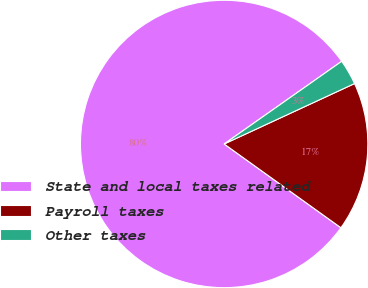<chart> <loc_0><loc_0><loc_500><loc_500><pie_chart><fcel>State and local taxes related<fcel>Payroll taxes<fcel>Other taxes<nl><fcel>80.34%<fcel>16.81%<fcel>2.85%<nl></chart> 